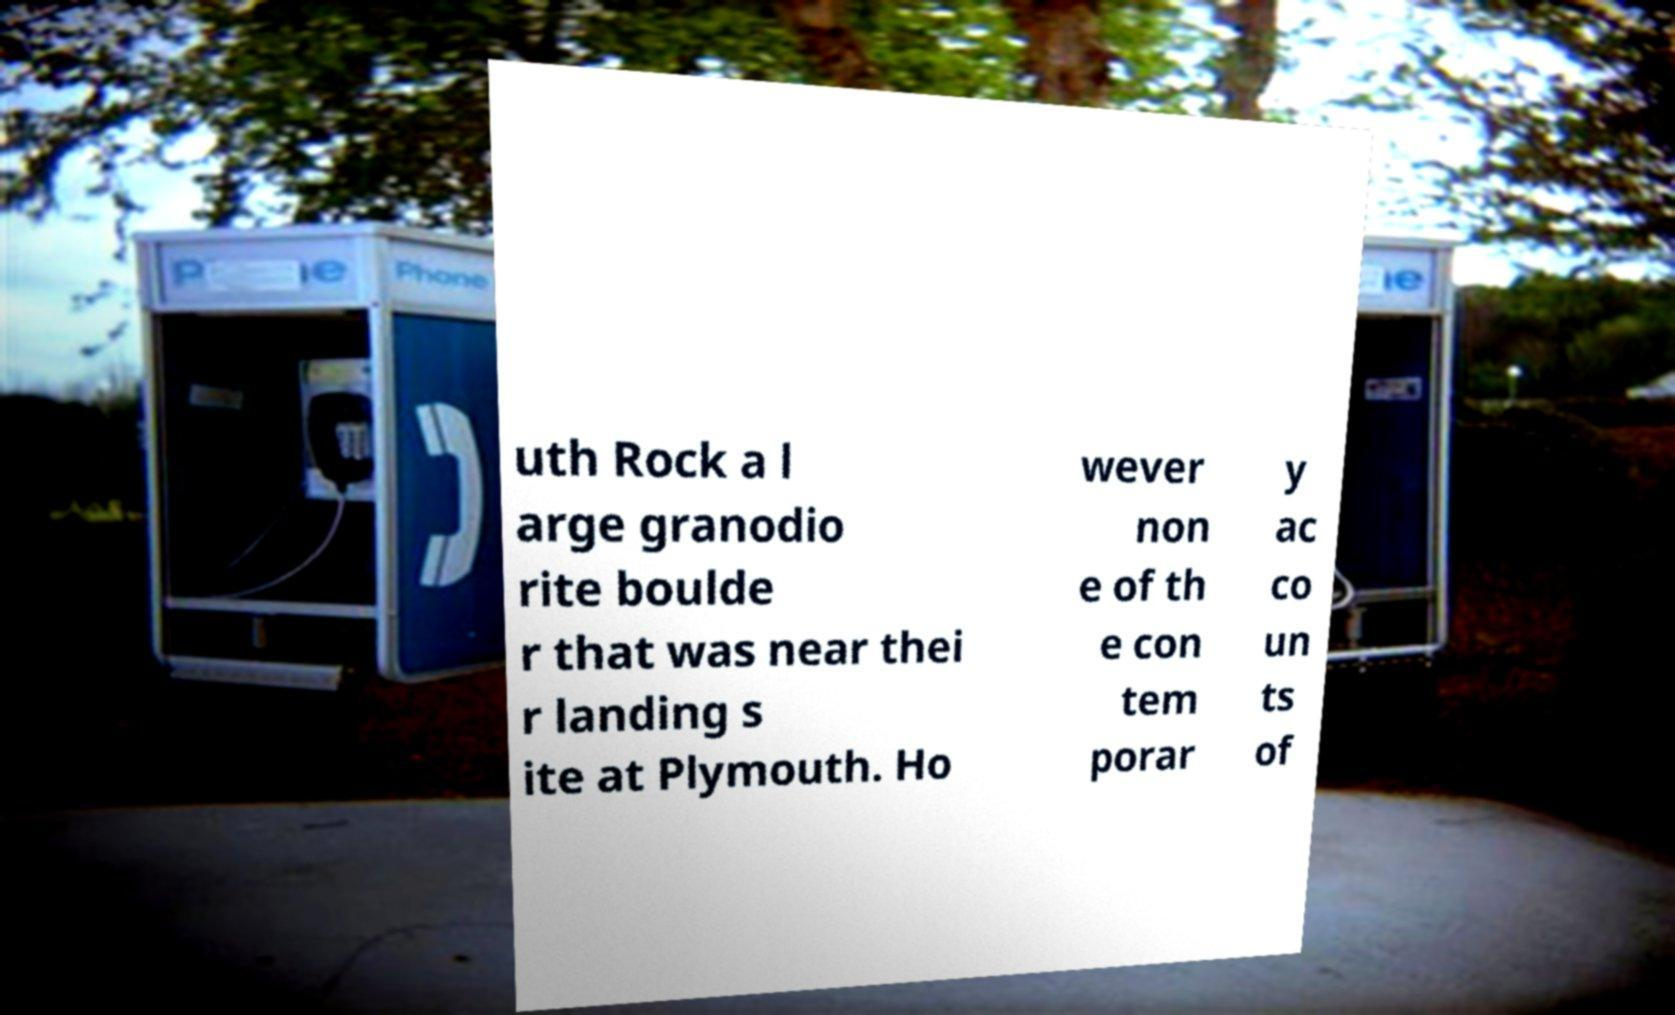Could you extract and type out the text from this image? uth Rock a l arge granodio rite boulde r that was near thei r landing s ite at Plymouth. Ho wever non e of th e con tem porar y ac co un ts of 